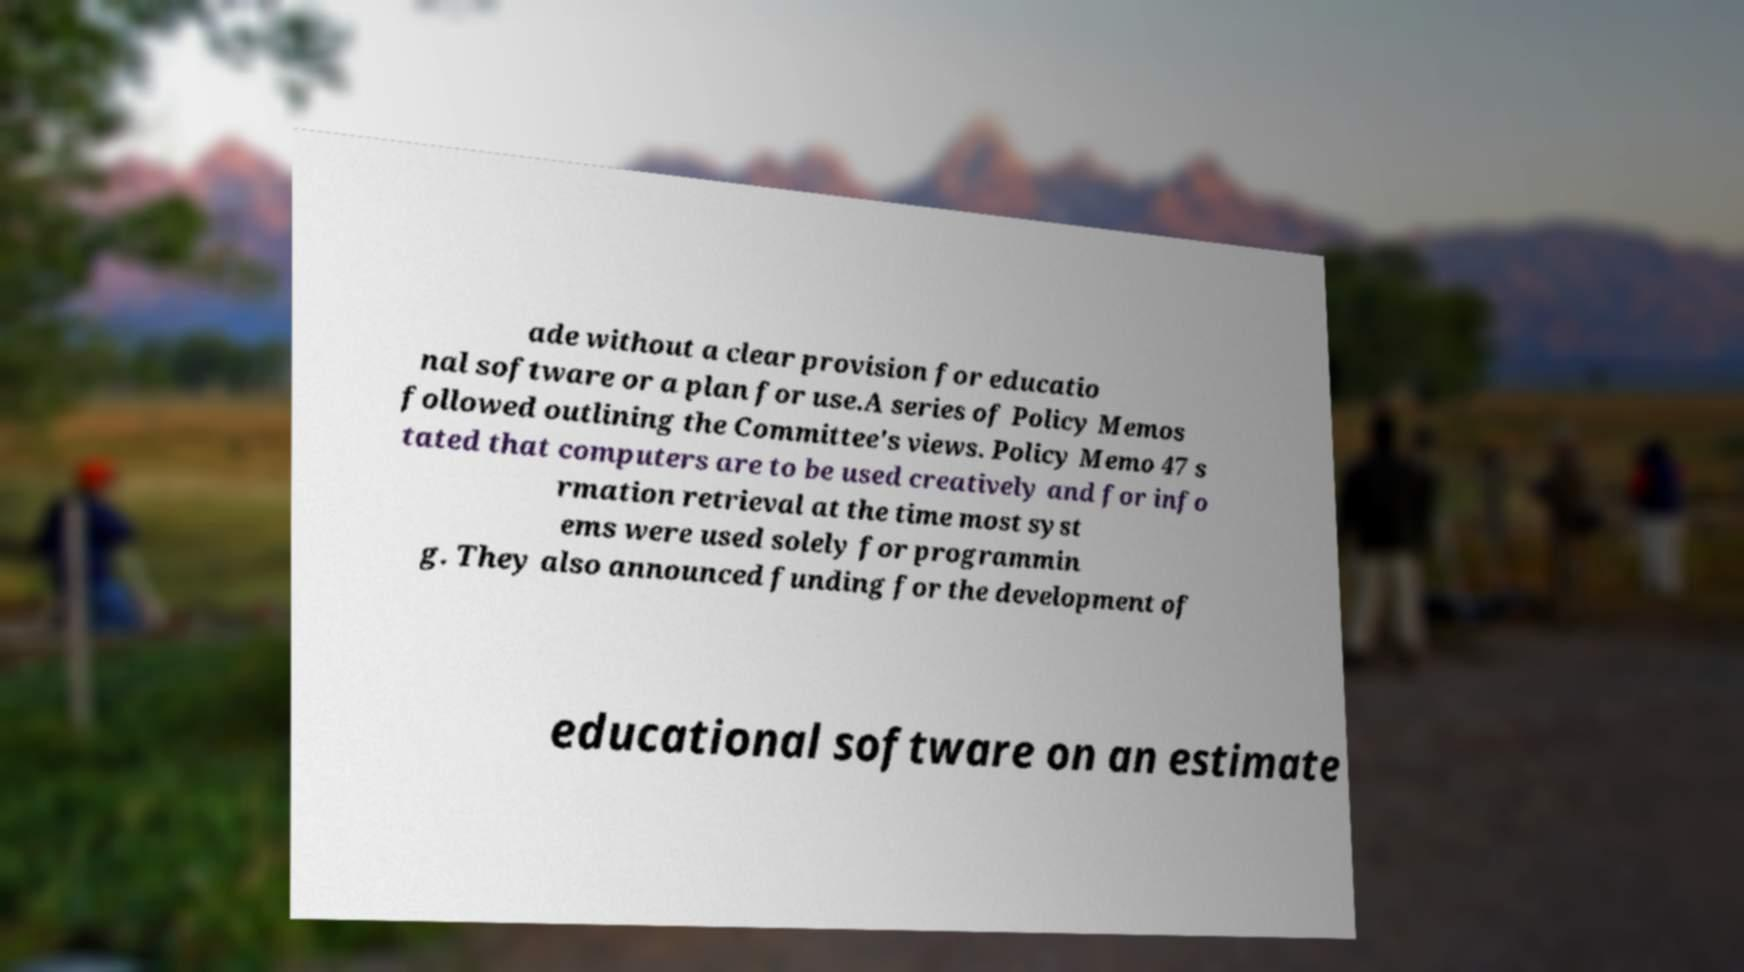Can you read and provide the text displayed in the image?This photo seems to have some interesting text. Can you extract and type it out for me? ade without a clear provision for educatio nal software or a plan for use.A series of Policy Memos followed outlining the Committee's views. Policy Memo 47 s tated that computers are to be used creatively and for info rmation retrieval at the time most syst ems were used solely for programmin g. They also announced funding for the development of educational software on an estimate 